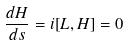<formula> <loc_0><loc_0><loc_500><loc_500>\frac { d H } { d s } = i [ L , H ] = 0</formula> 